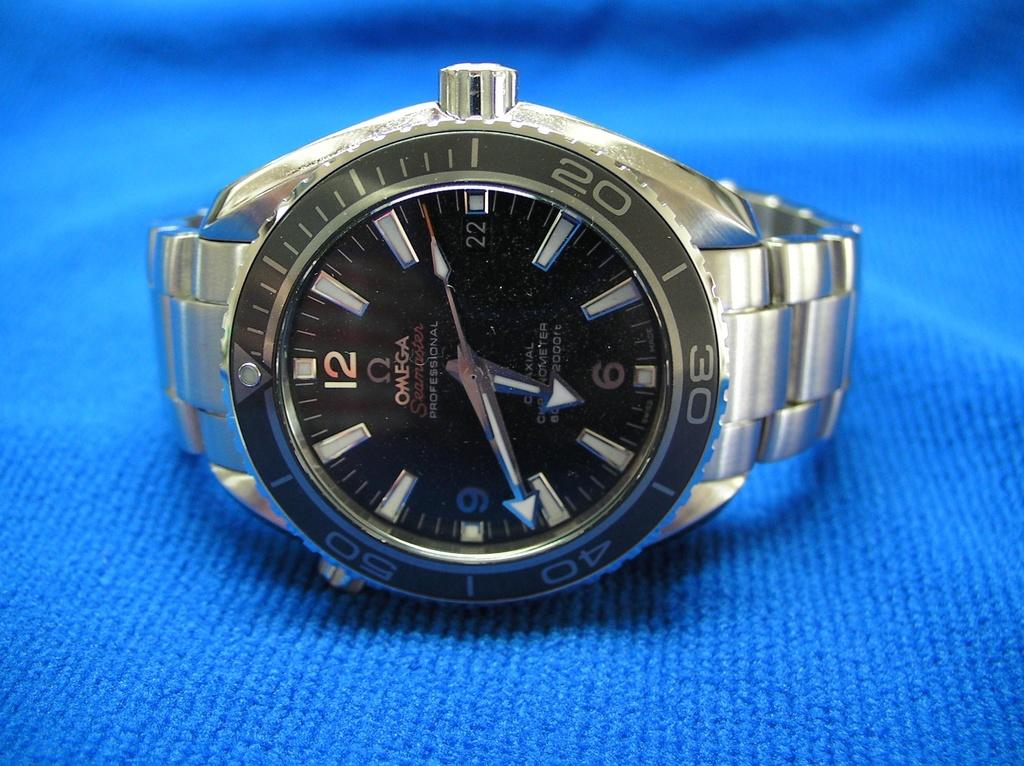<image>
Give a short and clear explanation of the subsequent image. An omega seamaster professional watch sits on a towel. 